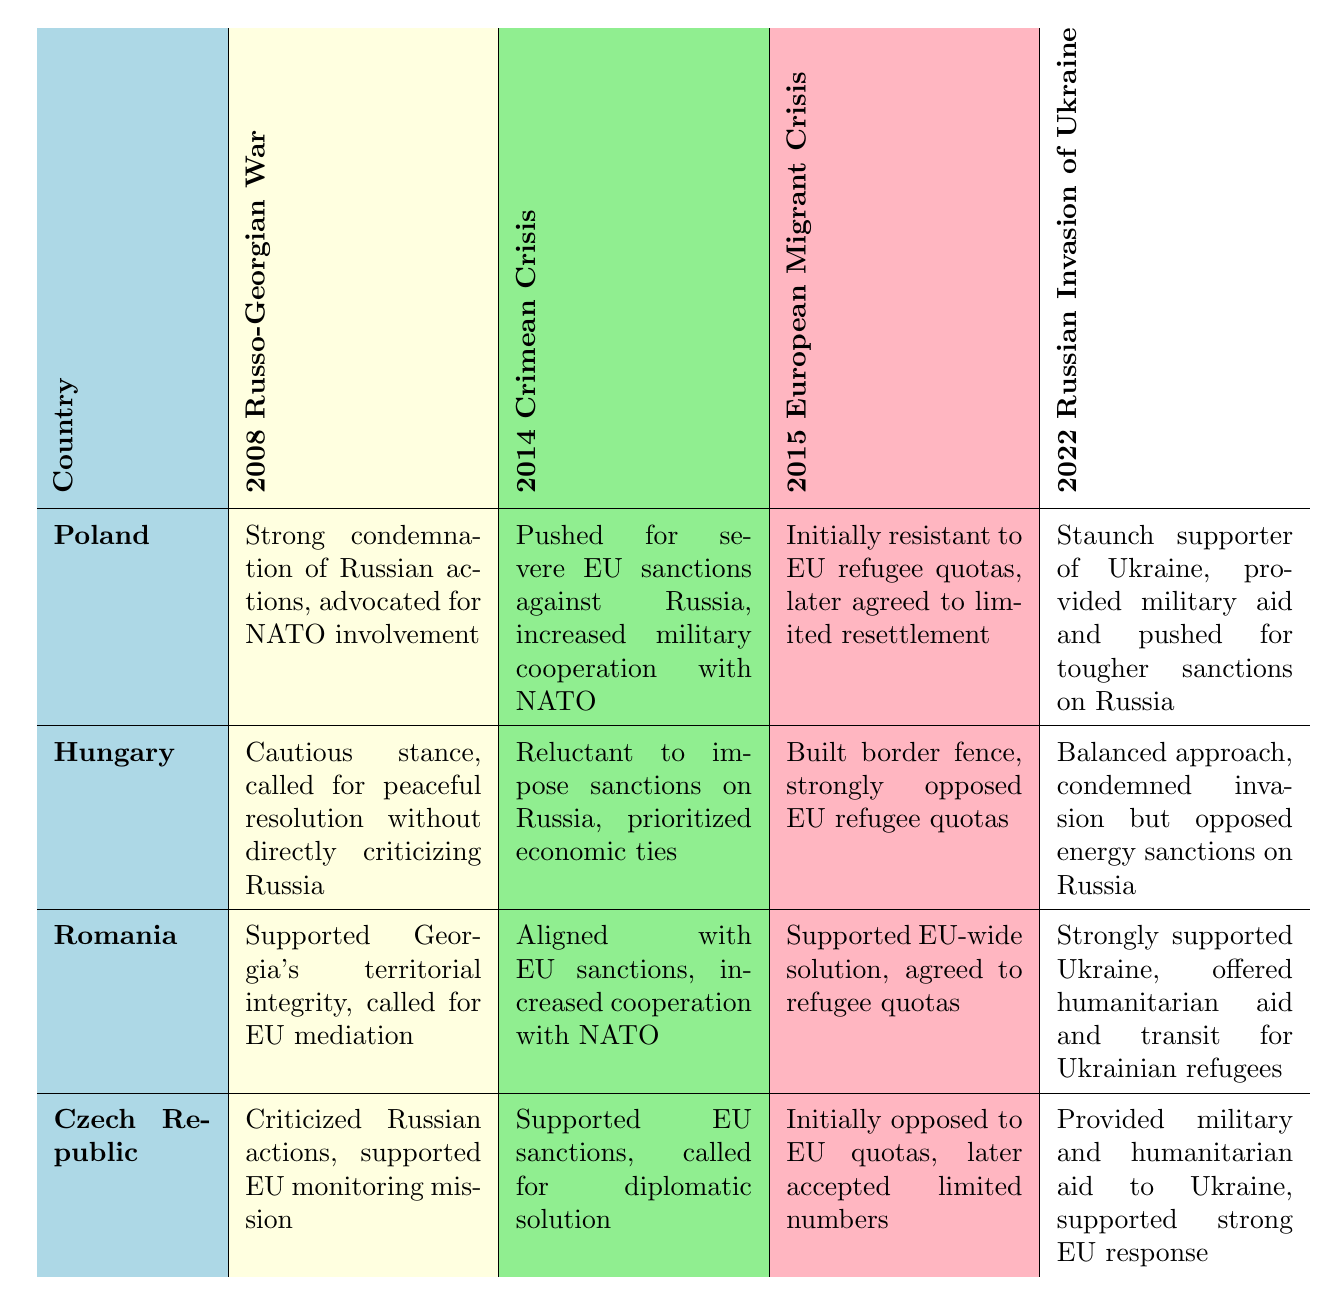What was Poland's diplomatic approach during the 2008 Russo-Georgian War? Poland's approach was to give a strong condemnation of Russian actions and advocate for NATO involvement. This can be found in the row corresponding to Poland and the column for the 2008 Russo-Georgian War.
Answer: Strong condemnation of Russian actions, advocated for NATO involvement Did Hungary take a supportive stance towards EU sanctions during the 2014 Crimean Crisis? According to the table, Hungary was reluctant to impose sanctions on Russia during the 2014 Crimean Crisis, indicating a lack of support for EU sanctions. This is summarized in the '2014 Crimean Crisis' cell under Hungary.
Answer: No Which country accepted limited numbers of refugees during the 2015 European Migrant Crisis? Both the Czech Republic and Poland initially opposed EU quotas but later accepted limited numbers. Therefore, referencing the rows for both countries in the 2015 column indicates that both accepted refugees.
Answer: Poland and Czech Republic What is the difference between Poland’s and Romania’s approach to the 2022 Russian Invasion of Ukraine? In the table, Poland is noted as a staunch supporter of Ukraine providing military aid and pushing for tougher sanctions on Russia, while Romania offered humanitarian aid and transit for Ukrainian refugees, showing a more humanitarian focus.
Answer: Poland focused on military aid, Romania on humanitarian aid What was the notable action of Radosław Sikorski during the 2014 Crimean Crisis? Radosław Sikorski advocated for a stronger Western response during the Crimean Crisis, as stated in the notable action for Poland in the key diplomats section.
Answer: Advocated for stronger Western response during Crimean Crisis How many countries supported the EU-wide solution during the 2015 European Migrant Crisis? The table indicates that only Romania explicitly supported an EU-wide solution and agreed to refugee quotas. Thus, the answer is one country.
Answer: One country What was unique about Hungary's approach to the 2022 Russian Invasion of Ukraine compared to other countries? Hungary’s balanced approach included condemning the invasion while opposing energy sanctions on Russia, differentiating it from other countries that were more focused on military support or total sanctions.
Answer: Balanced approach, condemned invasion but opposed energy sanctions Which country criticized Russian actions during the 2008 Russo-Georgian War? The Czech Republic criticized Russian actions and supported the EU monitoring mission, as shown in the row for the Czech Republic under the 2008 Russo-Georgian War column.
Answer: Czech Republic How did Romania's diplomatic approach differ from Hungary's during the 2014 Crimean Crisis? Romania aligned with EU sanctions and increased cooperation with NATO, whereas Hungary was reluctant to impose sanctions and prioritized economic ties with Russia. This showcases a significant difference in their diplomatic strategies.
Answer: Romania supported EU sanctions, Hungary did not 